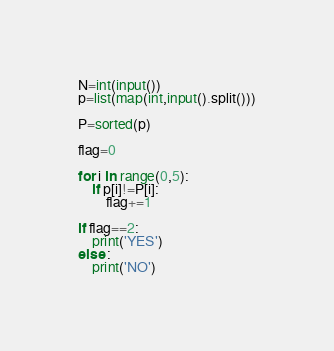Convert code to text. <code><loc_0><loc_0><loc_500><loc_500><_Python_>N=int(input())
p=list(map(int,input().split()))

P=sorted(p)

flag=0

for i in range(0,5):
    if p[i]!=P[i]:
        flag+=1

if flag==2:
    print('YES')
else :
    print('NO')</code> 